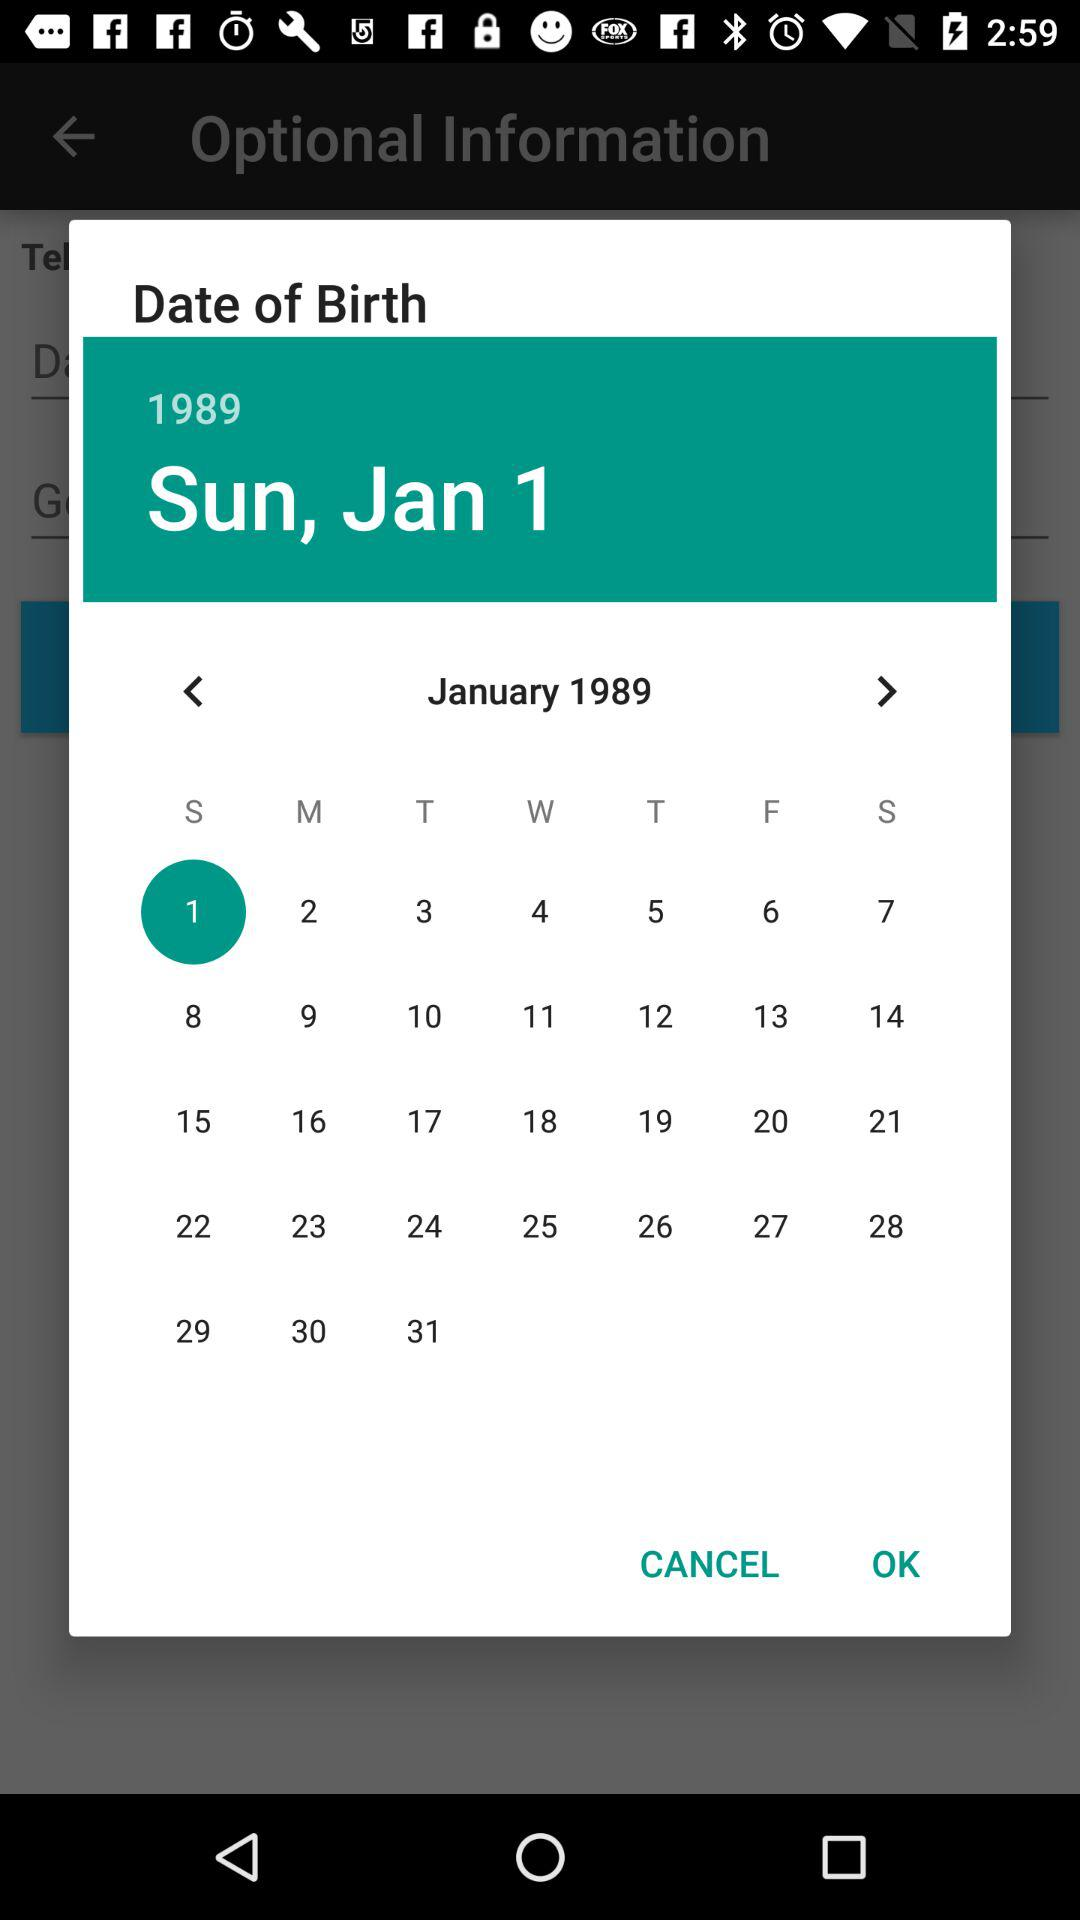What is the day of the selected date? The day is Sunday. 